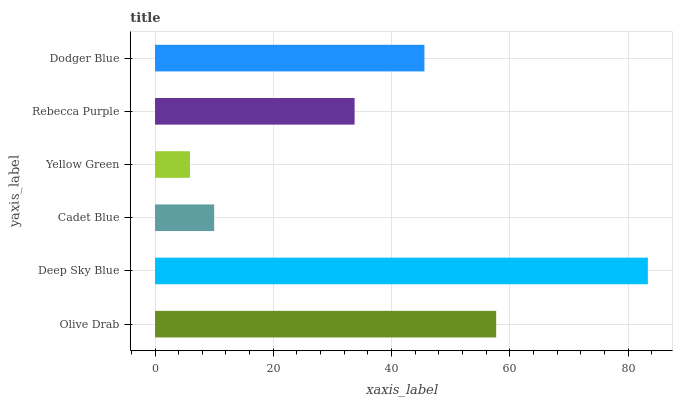Is Yellow Green the minimum?
Answer yes or no. Yes. Is Deep Sky Blue the maximum?
Answer yes or no. Yes. Is Cadet Blue the minimum?
Answer yes or no. No. Is Cadet Blue the maximum?
Answer yes or no. No. Is Deep Sky Blue greater than Cadet Blue?
Answer yes or no. Yes. Is Cadet Blue less than Deep Sky Blue?
Answer yes or no. Yes. Is Cadet Blue greater than Deep Sky Blue?
Answer yes or no. No. Is Deep Sky Blue less than Cadet Blue?
Answer yes or no. No. Is Dodger Blue the high median?
Answer yes or no. Yes. Is Rebecca Purple the low median?
Answer yes or no. Yes. Is Yellow Green the high median?
Answer yes or no. No. Is Dodger Blue the low median?
Answer yes or no. No. 